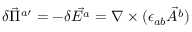<formula> <loc_0><loc_0><loc_500><loc_500>\delta \vec { \Pi } ^ { a \prime } = - \delta \vec { E ^ { a } } = \nabla \times ( \epsilon _ { a b } \vec { A ^ { b } } )</formula> 